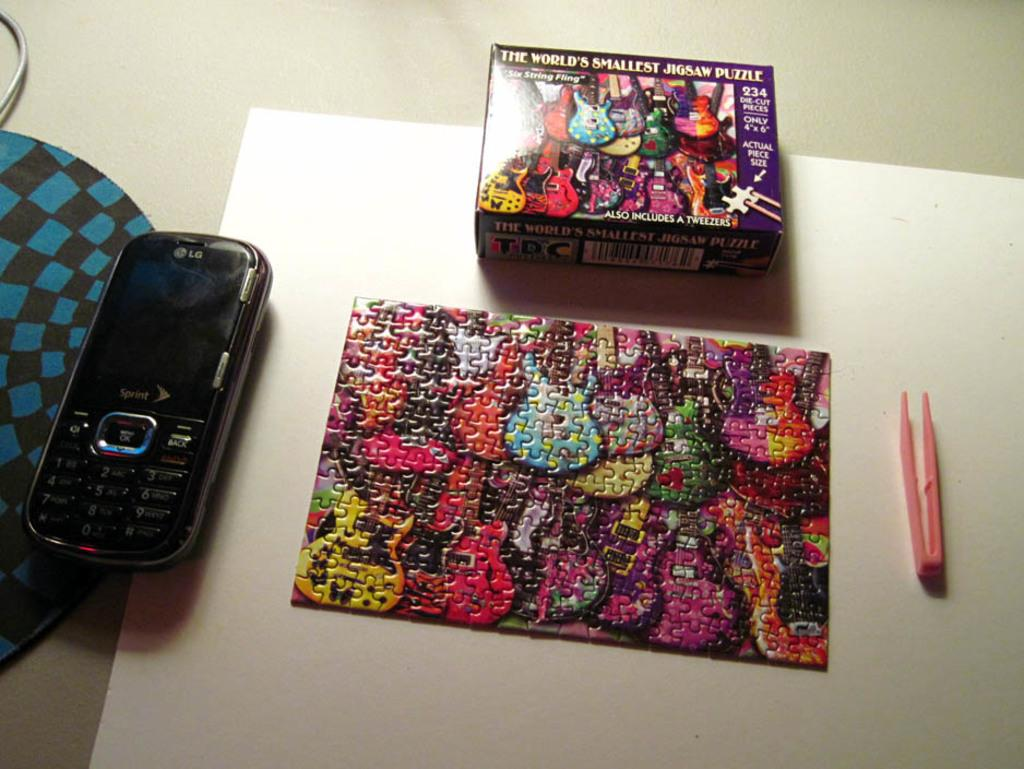<image>
Provide a brief description of the given image. A fiinizhed jigsaw puzzle is on the table top in front of the box that says "The world's smallest jigsaw puzzle." 